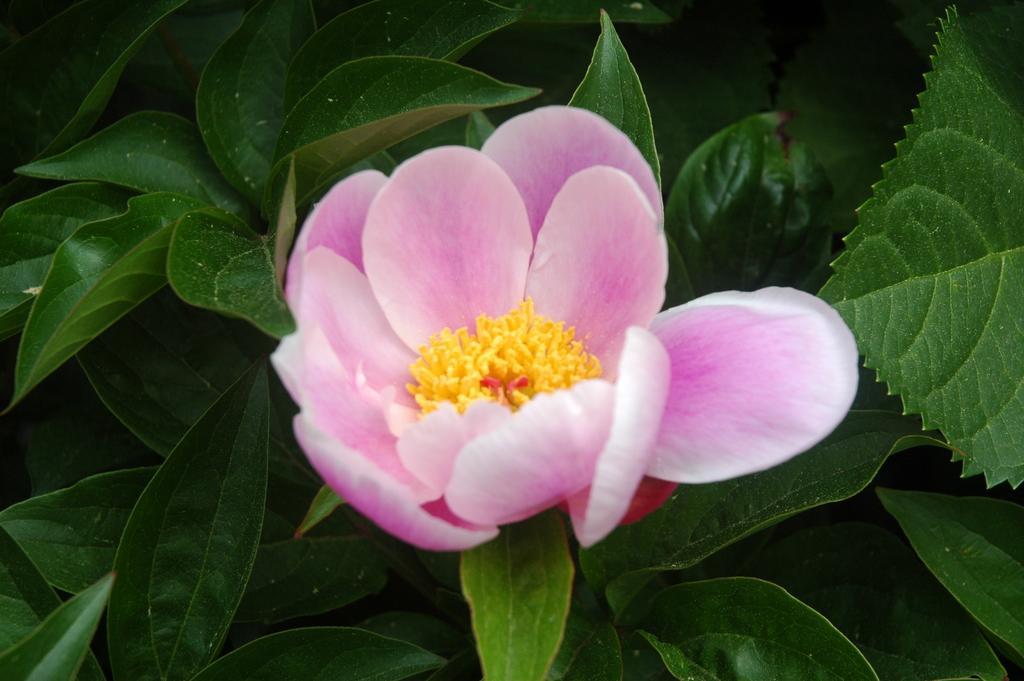Please provide a concise description of this image. In this picture we can see a flower and leaves. 